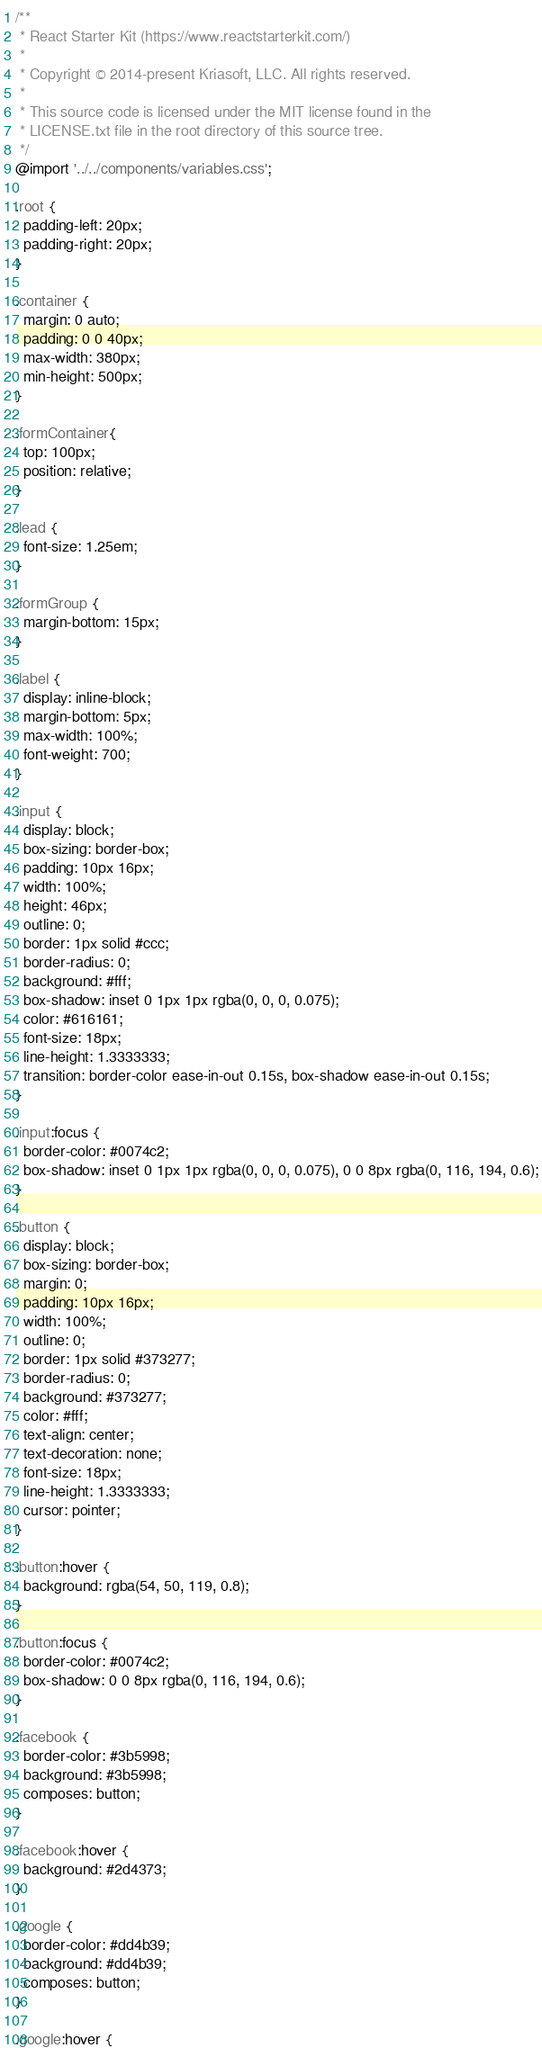<code> <loc_0><loc_0><loc_500><loc_500><_CSS_>/**
 * React Starter Kit (https://www.reactstarterkit.com/)
 *
 * Copyright © 2014-present Kriasoft, LLC. All rights reserved.
 *
 * This source code is licensed under the MIT license found in the
 * LICENSE.txt file in the root directory of this source tree.
 */
@import '../../components/variables.css';

.root {
  padding-left: 20px;
  padding-right: 20px;
}

.container {
  margin: 0 auto;
  padding: 0 0 40px;
  max-width: 380px;
  min-height: 500px;
}

.formContainer{
  top: 100px;
  position: relative;
}

.lead {
  font-size: 1.25em;
}

.formGroup {
  margin-bottom: 15px;
}

.label {
  display: inline-block;
  margin-bottom: 5px;
  max-width: 100%;
  font-weight: 700;
}

.input {
  display: block;
  box-sizing: border-box;
  padding: 10px 16px;
  width: 100%;
  height: 46px;
  outline: 0;
  border: 1px solid #ccc;
  border-radius: 0;
  background: #fff;
  box-shadow: inset 0 1px 1px rgba(0, 0, 0, 0.075);
  color: #616161;
  font-size: 18px;
  line-height: 1.3333333;
  transition: border-color ease-in-out 0.15s, box-shadow ease-in-out 0.15s;
}

.input:focus {
  border-color: #0074c2;
  box-shadow: inset 0 1px 1px rgba(0, 0, 0, 0.075), 0 0 8px rgba(0, 116, 194, 0.6);
}

.button {
  display: block;
  box-sizing: border-box;
  margin: 0;
  padding: 10px 16px;
  width: 100%;
  outline: 0;
  border: 1px solid #373277;
  border-radius: 0;
  background: #373277;
  color: #fff;
  text-align: center;
  text-decoration: none;
  font-size: 18px;
  line-height: 1.3333333;
  cursor: pointer;
}

.button:hover {
  background: rgba(54, 50, 119, 0.8);
}

.button:focus {
  border-color: #0074c2;
  box-shadow: 0 0 8px rgba(0, 116, 194, 0.6);
}

.facebook {
  border-color: #3b5998;
  background: #3b5998;
  composes: button;
}

.facebook:hover {
  background: #2d4373;
}

.google {
  border-color: #dd4b39;
  background: #dd4b39;
  composes: button;
}

.google:hover {</code> 